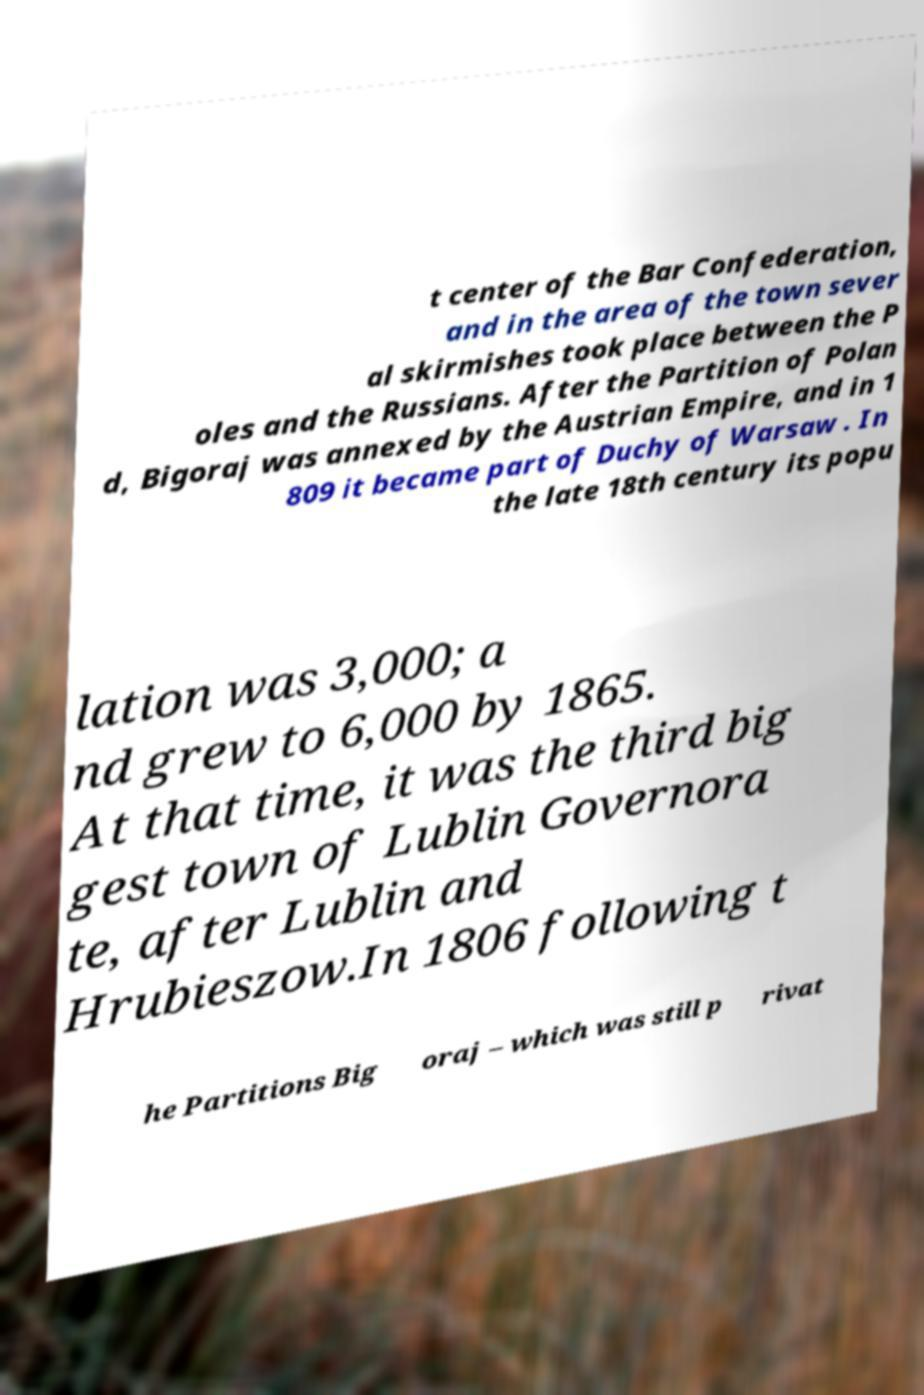There's text embedded in this image that I need extracted. Can you transcribe it verbatim? t center of the Bar Confederation, and in the area of the town sever al skirmishes took place between the P oles and the Russians. After the Partition of Polan d, Bigoraj was annexed by the Austrian Empire, and in 1 809 it became part of Duchy of Warsaw . In the late 18th century its popu lation was 3,000; a nd grew to 6,000 by 1865. At that time, it was the third big gest town of Lublin Governora te, after Lublin and Hrubieszow.In 1806 following t he Partitions Big oraj – which was still p rivat 